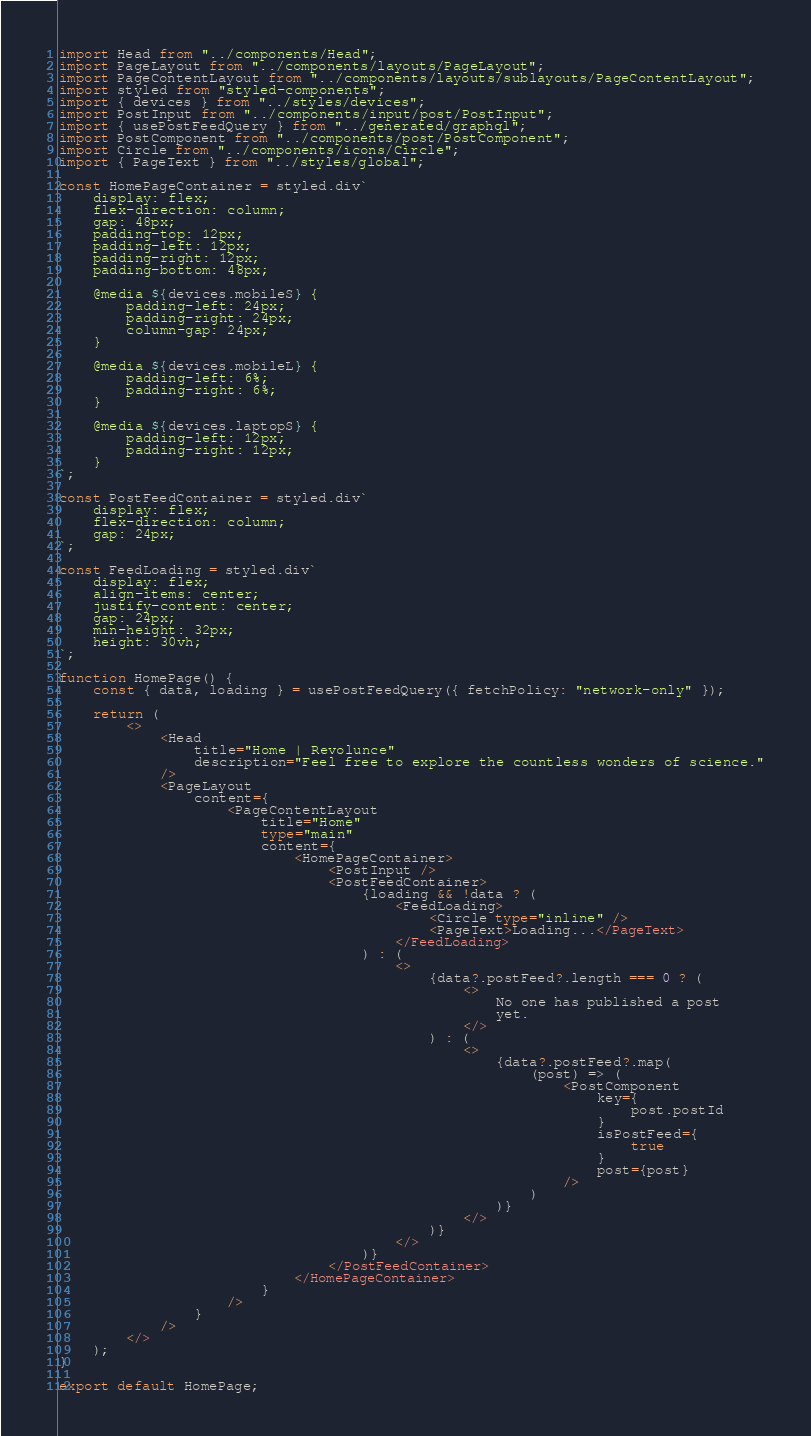Convert code to text. <code><loc_0><loc_0><loc_500><loc_500><_TypeScript_>import Head from "../components/Head";
import PageLayout from "../components/layouts/PageLayout";
import PageContentLayout from "../components/layouts/sublayouts/PageContentLayout";
import styled from "styled-components";
import { devices } from "../styles/devices";
import PostInput from "../components/input/post/PostInput";
import { usePostFeedQuery } from "../generated/graphql";
import PostComponent from "../components/post/PostComponent";
import Circle from "../components/icons/Circle";
import { PageText } from "../styles/global";

const HomePageContainer = styled.div`
    display: flex;
    flex-direction: column;
    gap: 48px;
    padding-top: 12px;
    padding-left: 12px;
    padding-right: 12px;
    padding-bottom: 48px;

    @media ${devices.mobileS} {
        padding-left: 24px;
        padding-right: 24px;
        column-gap: 24px;
    }

    @media ${devices.mobileL} {
        padding-left: 6%;
        padding-right: 6%;
    }

    @media ${devices.laptopS} {
        padding-left: 12px;
        padding-right: 12px;
    }
`;

const PostFeedContainer = styled.div`
    display: flex;
    flex-direction: column;
    gap: 24px;
`;

const FeedLoading = styled.div`
    display: flex;
    align-items: center;
    justify-content: center;
    gap: 24px;
    min-height: 32px;
    height: 30vh;
`;

function HomePage() {
    const { data, loading } = usePostFeedQuery({ fetchPolicy: "network-only" });

    return (
        <>
            <Head
                title="Home | Revolunce"
                description="Feel free to explore the countless wonders of science."
            />
            <PageLayout
                content={
                    <PageContentLayout
                        title="Home"
                        type="main"
                        content={
                            <HomePageContainer>
                                <PostInput />
                                <PostFeedContainer>
                                    {loading && !data ? (
                                        <FeedLoading>
                                            <Circle type="inline" />
                                            <PageText>Loading...</PageText>
                                        </FeedLoading>
                                    ) : (
                                        <>
                                            {data?.postFeed?.length === 0 ? (
                                                <>
                                                    No one has published a post
                                                    yet.
                                                </>
                                            ) : (
                                                <>
                                                    {data?.postFeed?.map(
                                                        (post) => (
                                                            <PostComponent
                                                                key={
                                                                    post.postId
                                                                }
                                                                isPostFeed={
                                                                    true
                                                                }
                                                                post={post}
                                                            />
                                                        )
                                                    )}
                                                </>
                                            )}
                                        </>
                                    )}
                                </PostFeedContainer>
                            </HomePageContainer>
                        }
                    />
                }
            />
        </>
    );
}

export default HomePage;
</code> 